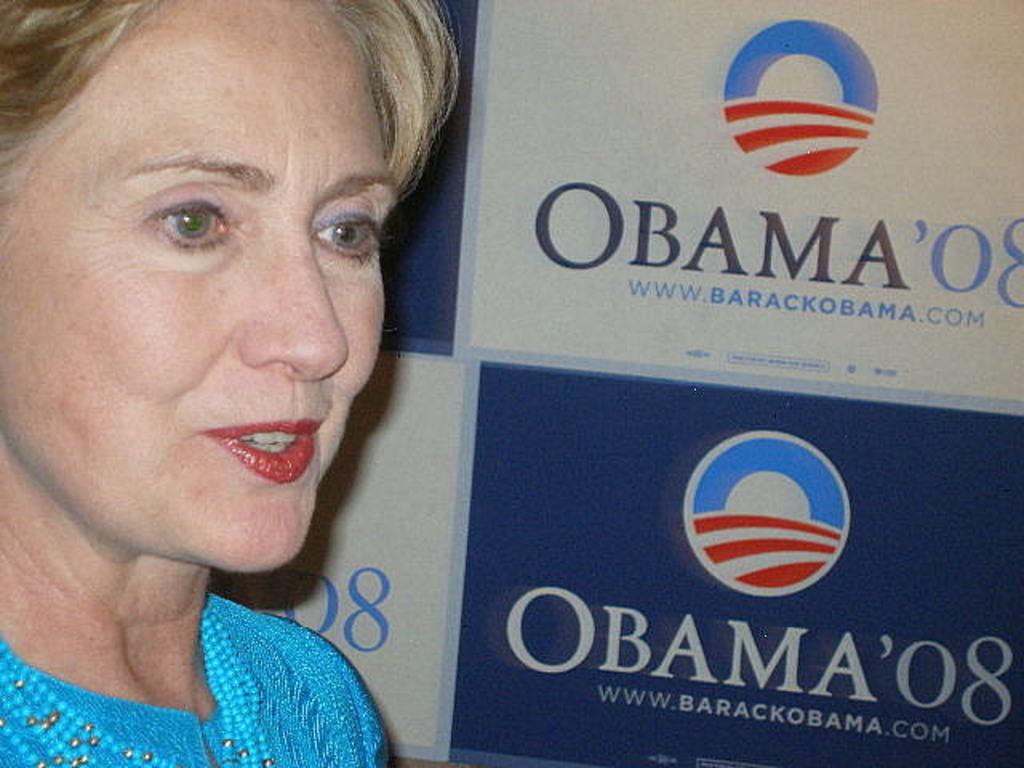Could you give a brief overview of what you see in this image? In this image we can see a person standing and we can see a banner with text and logo. 